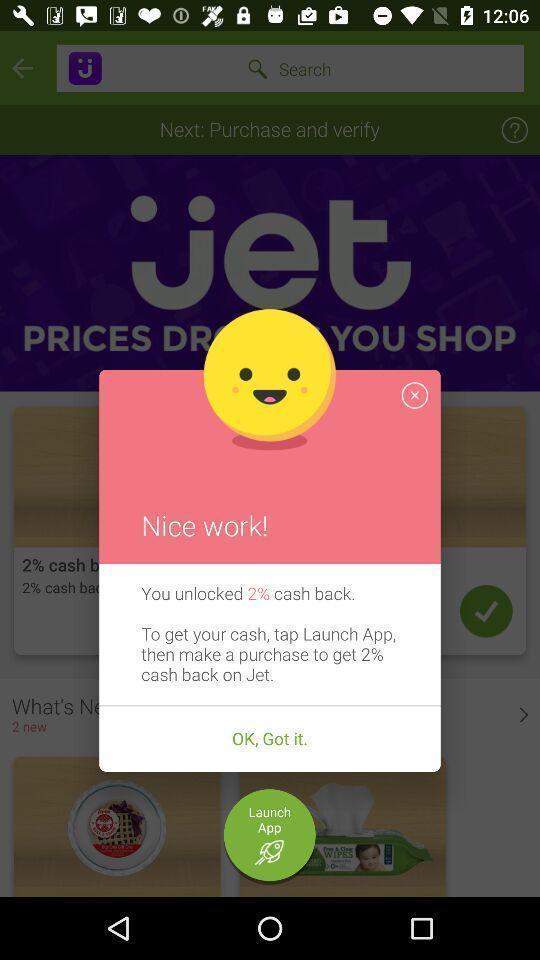What details can you identify in this image? Pop-up showing a cash back message. 